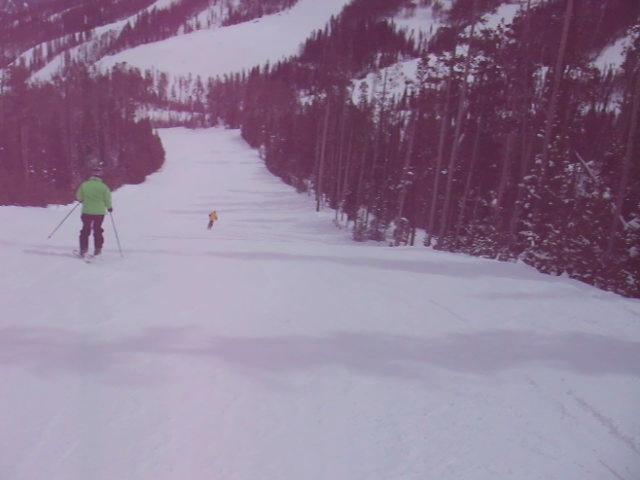What sport would this be if gates were added?
Answer the question by selecting the correct answer among the 4 following choices.
Options: Slalom, ski jump, moguls, downhill. Moguls. 